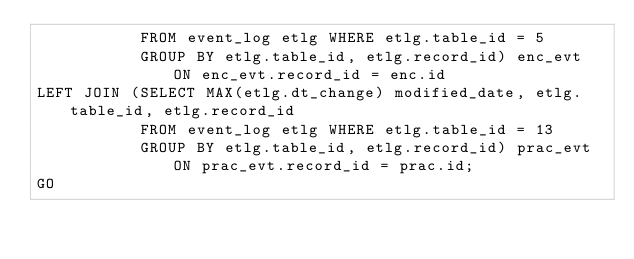Convert code to text. <code><loc_0><loc_0><loc_500><loc_500><_SQL_>           FROM event_log etlg WHERE etlg.table_id = 5
           GROUP BY etlg.table_id, etlg.record_id) enc_evt ON enc_evt.record_id = enc.id
LEFT JOIN (SELECT MAX(etlg.dt_change) modified_date, etlg.table_id, etlg.record_id 
           FROM event_log etlg WHERE etlg.table_id = 13
           GROUP BY etlg.table_id, etlg.record_id) prac_evt ON prac_evt.record_id = prac.id;
GO
</code> 